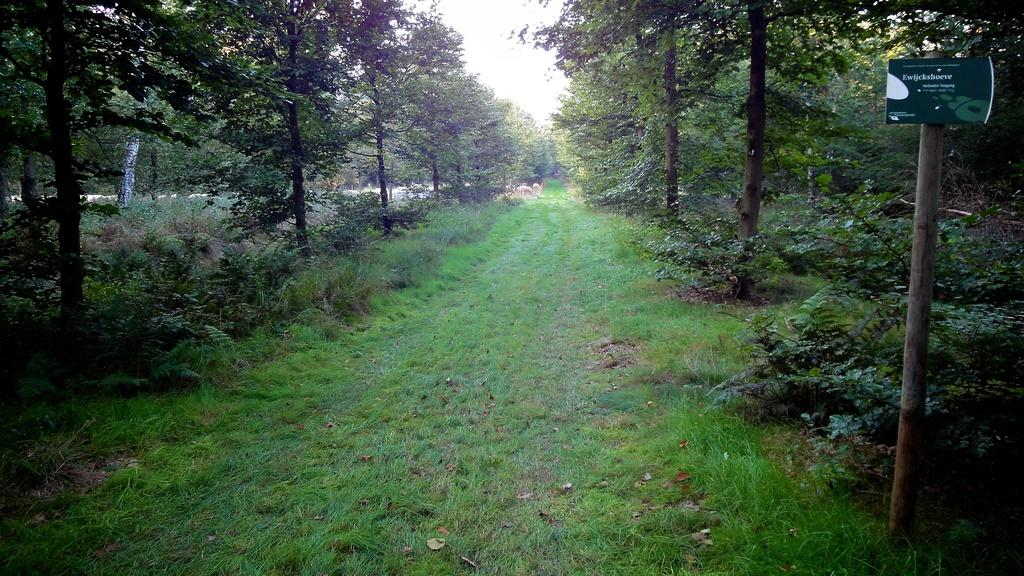What type of vegetation is present in the image? There is grass in the image. What can be seen on both sides of the path? There are trees on both sides of the path. What is present on the ground in the image? There are plants on the ground. What can be seen in the background of the image? In the background, there are animals and trees. What part of the natural environment is visible in the image? The sky is visible in the background. What is the reaction of the grass when the animals approach in the image? The grass does not have a reaction, as it is an inanimate object. 